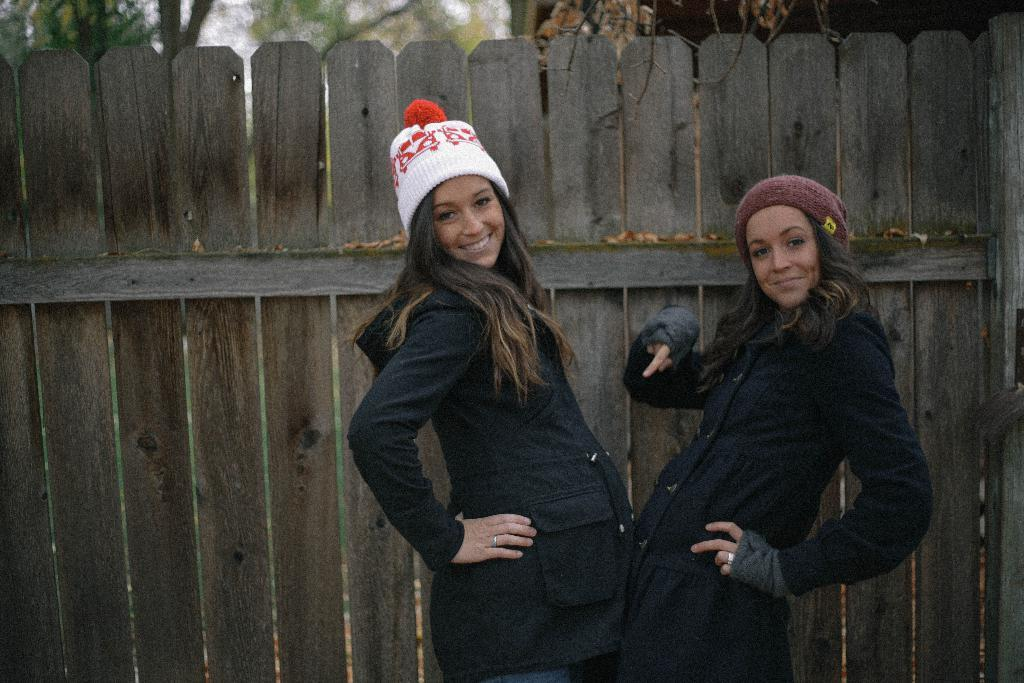How many people are present in the image? There are two people standing in the image. What is the facial expression of the people in the image? The people are smiling. What can be seen in the background of the image? There is a wooden railing, trees, and possibly a building in the background of the image. What is visible at the top of the image? The sky is visible at the top of the image. What type of jam is being sold by the people in the image? There is no jam or any indication of a sale in the image; it features two people standing and smiling. What is the profit margin for the flowers being sold by the people in the image? There are no flowers or any indication of a sale in the image, so it's not possible to determine the profit margin. 